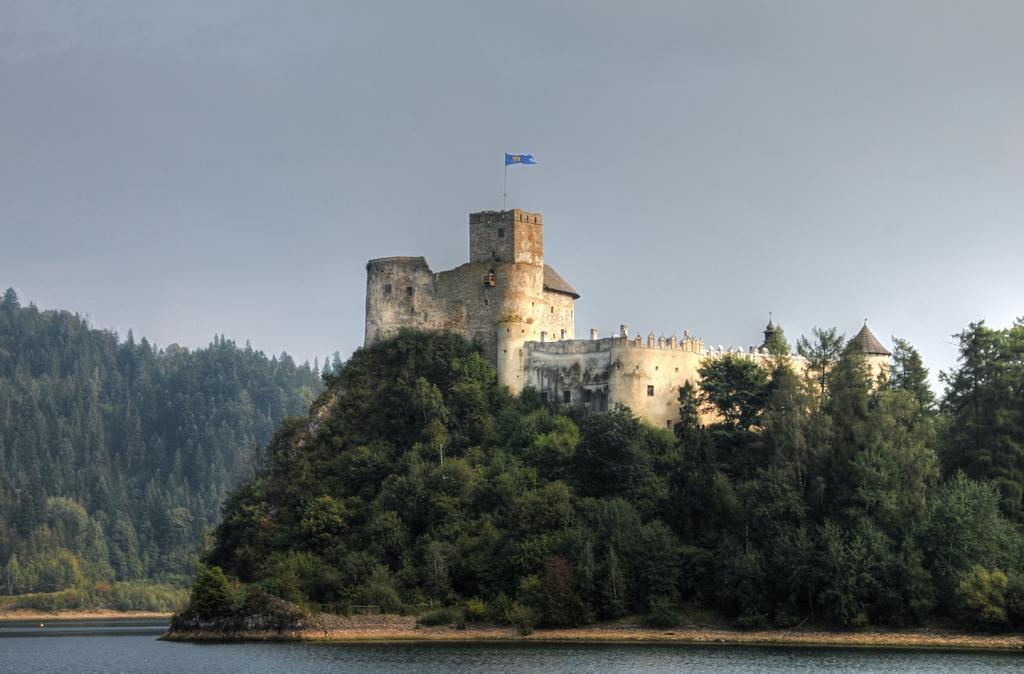In one or two sentences, can you explain what this image depicts? There is a surface of water at the bottom of this image, and there are some trees in the background. There is a monument with a flag as we can see in the middle of this image, and there is a sky at the top of this image. 